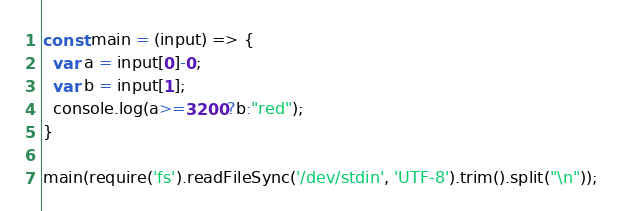Convert code to text. <code><loc_0><loc_0><loc_500><loc_500><_JavaScript_>const main = (input) => {
  var a = input[0]-0;
  var b = input[1];
  console.log(a>=3200?b:"red");
}

main(require('fs').readFileSync('/dev/stdin', 'UTF-8').trim().split("\n"));
</code> 